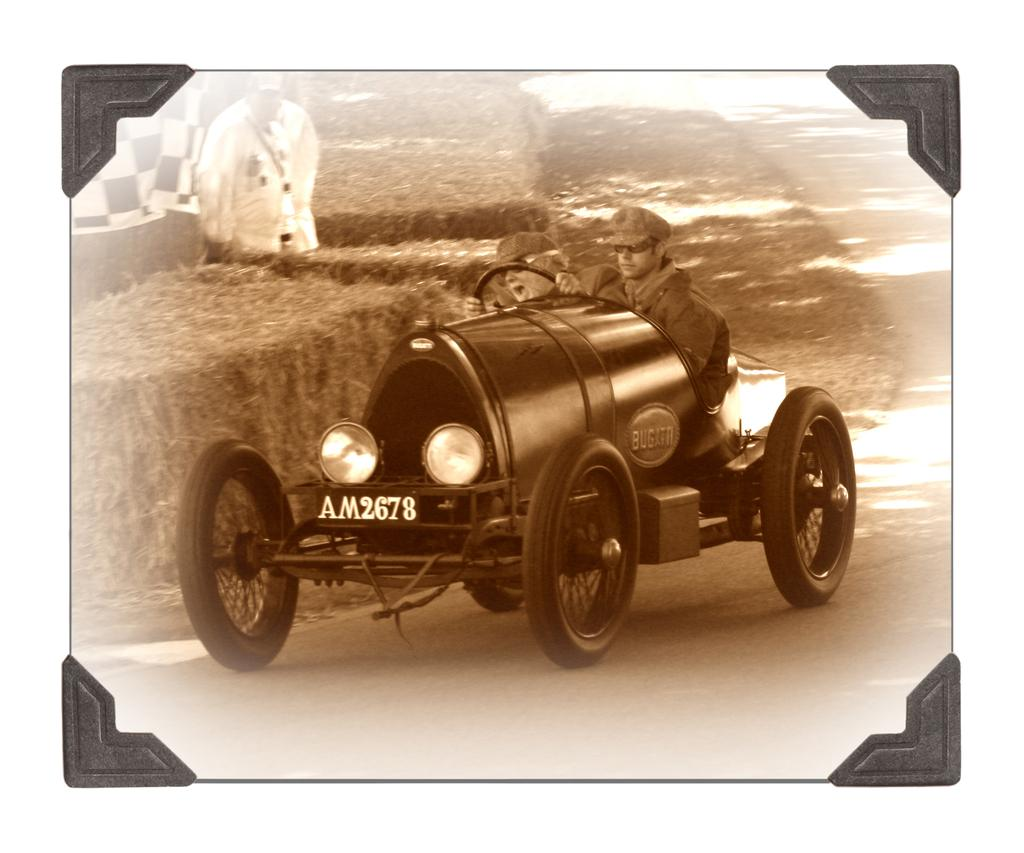What is the main object in the image? There is a frame in the image. What are the two persons on the vehicle doing? The two persons on the vehicle are riding it. What are the persons wearing on their heads? The persons are wearing caps. Can you describe the setting of the image? There is grass visible in the image. What route are the persons taking in the image? There is no information about a route in the image. What are the persons learning while riding the vehicle? There is no indication of any learning activity in the image. 